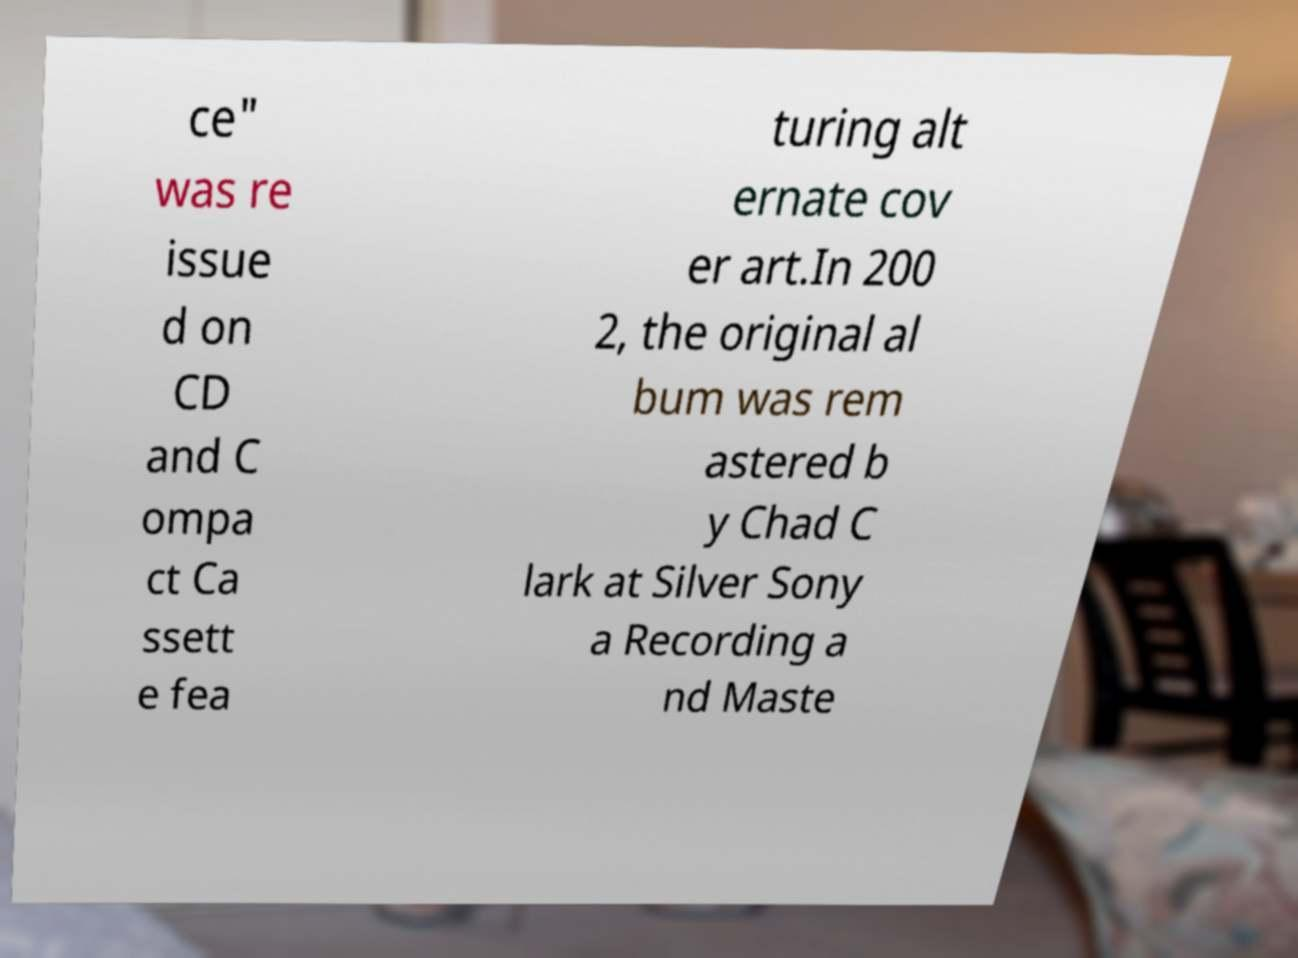Can you read and provide the text displayed in the image?This photo seems to have some interesting text. Can you extract and type it out for me? ce" was re issue d on CD and C ompa ct Ca ssett e fea turing alt ernate cov er art.In 200 2, the original al bum was rem astered b y Chad C lark at Silver Sony a Recording a nd Maste 